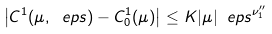Convert formula to latex. <formula><loc_0><loc_0><loc_500><loc_500>\left | C ^ { 1 } ( \mu , \ e p s ) - C _ { 0 } ^ { 1 } ( \mu ) \right | \leq K | \mu | \ e p s ^ { \nu _ { 1 } ^ { \prime \prime } }</formula> 